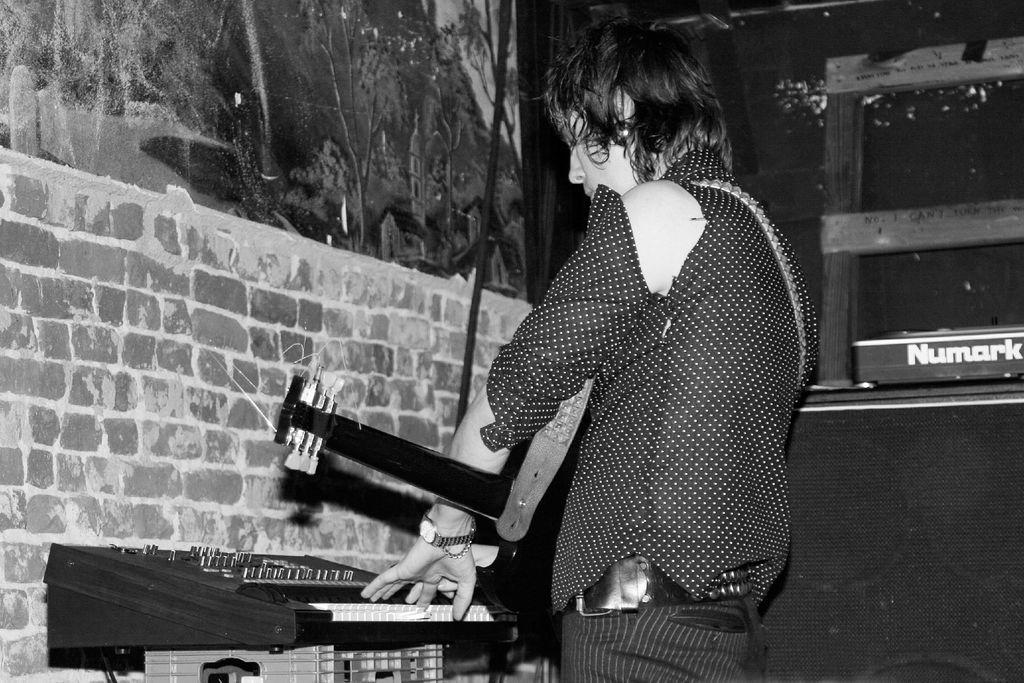What is the main subject of the image? There is a woman in the image. What is the woman doing in the image? The woman is standing and playing a musical instrument. What is in front of the woman in the image? There is a brick wall in front of the woman. What color is the cloth visible in the background? The cloth visible in the background is black. What is the color scheme of the image? The image is in black and white. What type of force is being applied by the police in the image? There is no police presence or force being applied in the image; it features a woman playing a musical instrument. What type of vest is the woman wearing in the image? The image is in black and white, and there is no indication of a vest being worn by the woman. 